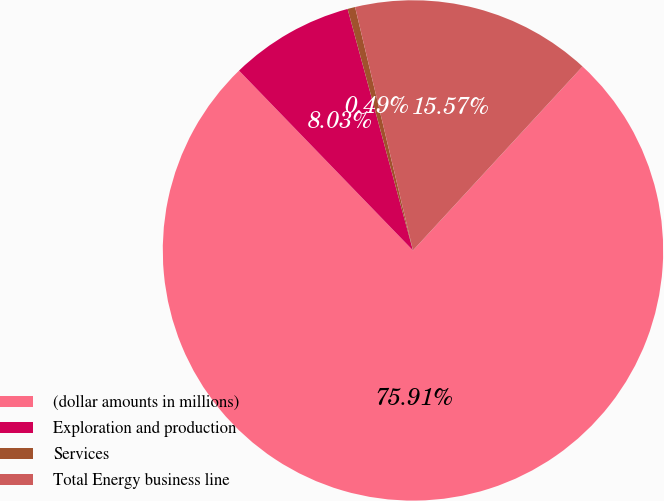Convert chart. <chart><loc_0><loc_0><loc_500><loc_500><pie_chart><fcel>(dollar amounts in millions)<fcel>Exploration and production<fcel>Services<fcel>Total Energy business line<nl><fcel>75.91%<fcel>8.03%<fcel>0.49%<fcel>15.57%<nl></chart> 